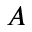Convert formula to latex. <formula><loc_0><loc_0><loc_500><loc_500>A</formula> 